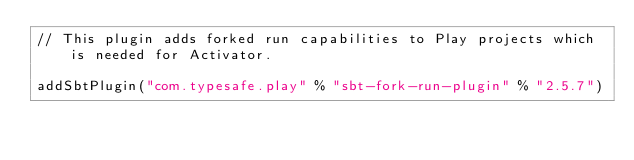Convert code to text. <code><loc_0><loc_0><loc_500><loc_500><_Scala_>// This plugin adds forked run capabilities to Play projects which is needed for Activator.

addSbtPlugin("com.typesafe.play" % "sbt-fork-run-plugin" % "2.5.7")</code> 